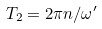Convert formula to latex. <formula><loc_0><loc_0><loc_500><loc_500>T _ { 2 } = 2 \pi n / \omega ^ { \prime }</formula> 